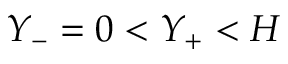<formula> <loc_0><loc_0><loc_500><loc_500>Y _ { - } = 0 < Y _ { + } < H</formula> 